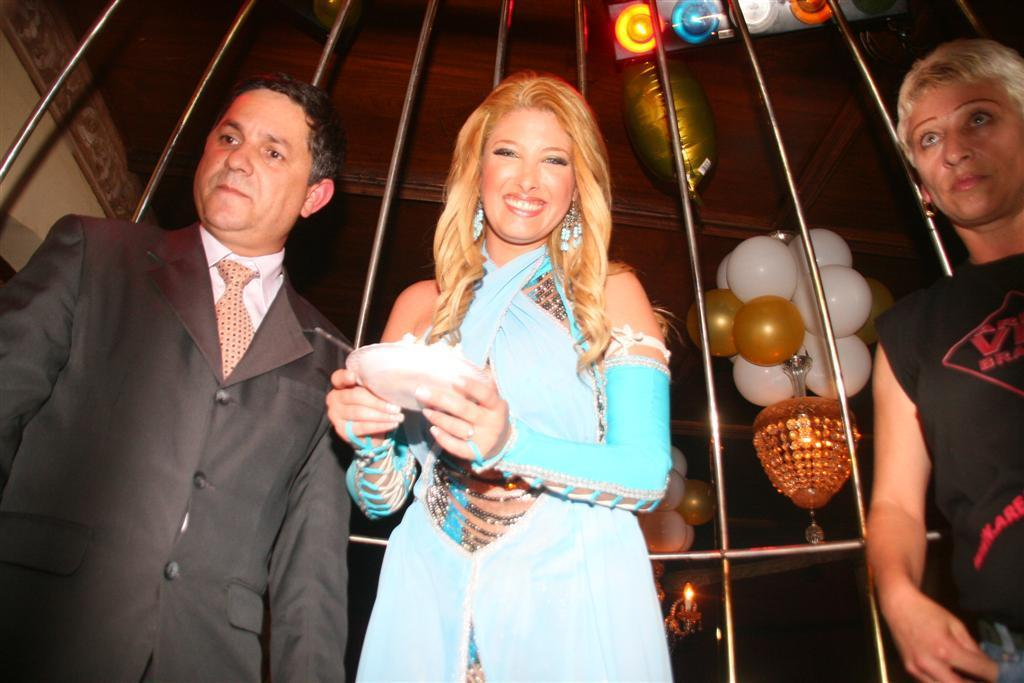How many people are in the image? There are three people standing in the front of the image. What can be seen behind the people? There is a wall in the image. What decorations are present in the image? There are balloons, a chandelier, and a candle in the image. How would you describe the lighting in the image? The background of the image is dark. What type of bean is being used for learning in the image? There is no bean or learning activity present in the image. 